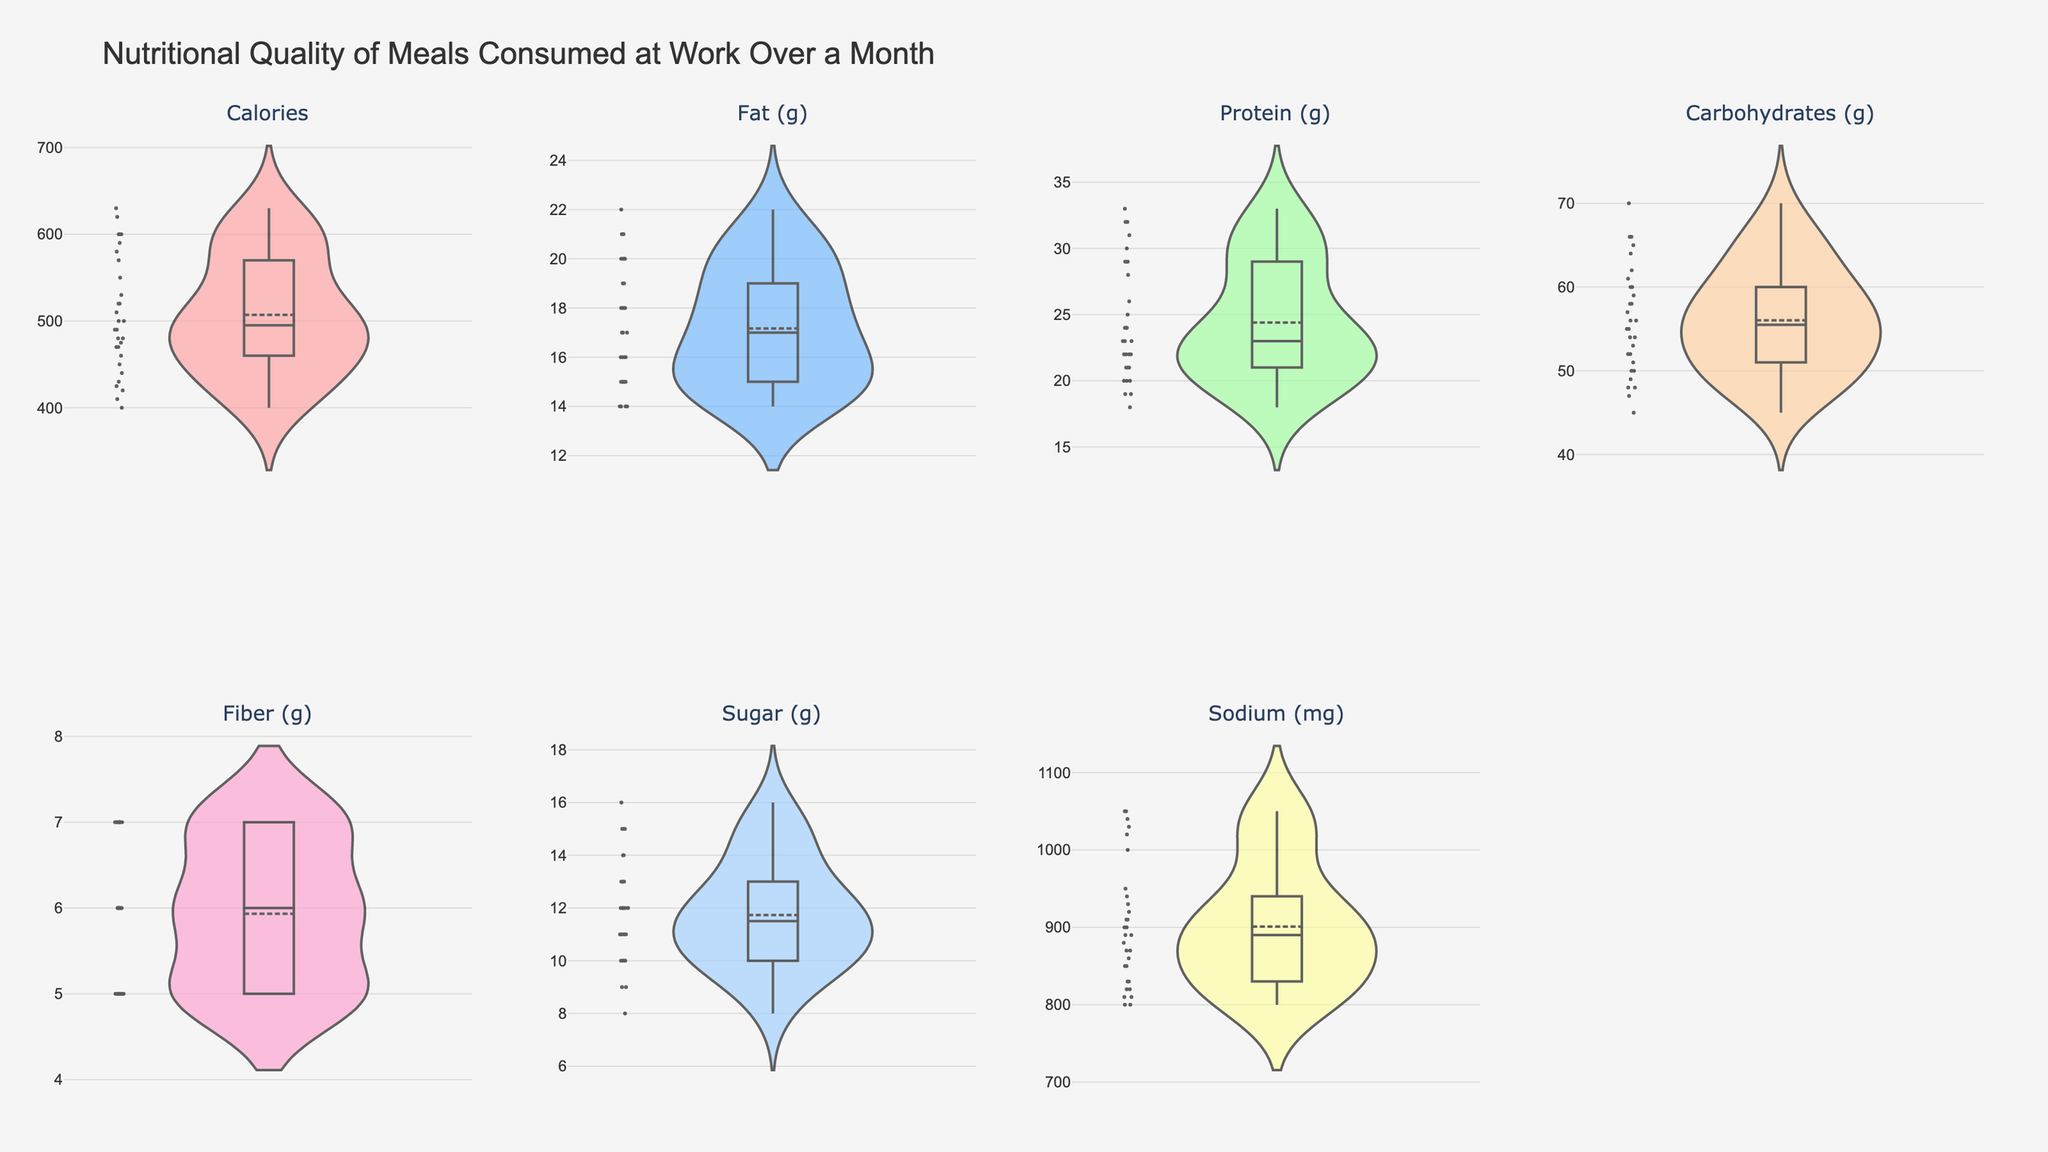What's the title of the figure? The title of the figure is placed at the top of the plot, in a larger font size than other text on the figure. This helps identify the main focus of the visualization.
Answer: Nutritional Quality of Meals Consumed at Work Over a Month How many different nutrients are shown in the figure? Nutrients are represented by different sections in the multiple subplot layout. Counting these sections will give the total number of distinct nutrients covered.
Answer: 7 What color is used to represent the "Calories" nutrient? Each nutrient in the figure is associated with a specific color to visually distinguish it from others. For "Calories", observe its plot's fill color.
Answer: Light Red Which nutrient has the widest range of values? The width of the violin plot at various parts indicates the density and spread of data. The nutrient with the widest part in its plot suggests the highest variability.
Answer: Sodium (mg) What is the median value for Protein (g)? The violin plots with a visible mean line also indicate the median value, often drawn by a middle line inside the plot. For "Protein (g)", locate this line within the respective plot.
Answer: 24 Which nutrient tends to have the highest values on average? Compare the central tendency (means/medians) of each violin plot. The nutrient with the highest central tendency values visualized through mean/median lines represents the highest average.
Answer: Calories Compare the mean values of "Fat (g)" and "Fiber (g)". Which one is higher? Look at the lines indicating the mean values in the plots for "Fat (g)" and "Fiber (g)". Comparing where these lines fall on their respective y-axes reveals which is higher.
Answer: Fat (g) What is the approximate range for Carbohydrates (g) based on the plot? Determine the lowest and highest points where the violin plot for "Carbohydrates (g)" extends along the y-axis. This span represents the nutrient's range.
Answer: Approximately 45 to 70 Which nutrient shows the least variation in their values? The violin plot with the least spread (narrowest range on the y-axis) suggests the least variation among its data points.
Answer: Fiber (g) Are there any outliers in the Sugar (g) data? Violin plots sometimes depict outliers via individual points or regions outside the main density. For "Sugar (g)", check if there are isolated points or extended parts.
Answer: No 